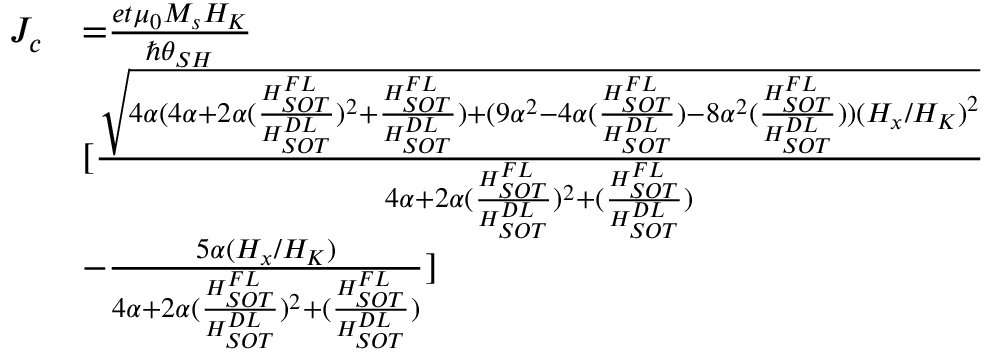Convert formula to latex. <formula><loc_0><loc_0><loc_500><loc_500>\begin{array} { l l } { J _ { c } } & { { = } \frac { e t { \mu } _ { 0 } M _ { s } H _ { K } } { { \hslash } { \theta } _ { S H } } } \\ & { [ \frac { \sqrt { { 4 } \alpha { ( 4 } \alpha { + 2 } \alpha ( \frac { H _ { S O T } ^ { F L } } { H _ { S O T } ^ { D L } } ) ^ { 2 } { + } \frac { H _ { S O T } ^ { F L } } { H _ { S O T } ^ { D L } } { ) + ( 9 } { \alpha } ^ { 2 } { - } { 4 } \alpha { ( } \frac { H _ { S O T } ^ { F L } } { H _ { S O T } ^ { D L } } { ) - 8 } { \alpha } ^ { 2 } { ( } \frac { H _ { S O T } ^ { F L } } { H _ { S O T } ^ { D L } } { ) ) } { { ( } H _ { x } { / } H _ { K } { ) } } ^ { 2 } } } { { { 4 } \alpha { + 2 } \alpha ( \frac { H _ { S O T } ^ { F L } } { H _ { S O T } ^ { D L } } ) ^ { 2 } { + ( } \frac { H _ { S O T } ^ { F L } } { H _ { S O T } ^ { D L } } { ) } } } } \\ & { { - } \frac { { 5 } \alpha { ( } H _ { x } { / } H _ { K } { ) } } { { 4 } \alpha { + 2 } \alpha ( \frac { H _ { S O T } ^ { F L } } { H _ { S O T } ^ { D L } } ) ^ { 2 } { + ( } \frac { H _ { S O T } ^ { F L } } { H _ { S O T } ^ { D L } } { ) } } ] } \end{array}</formula> 